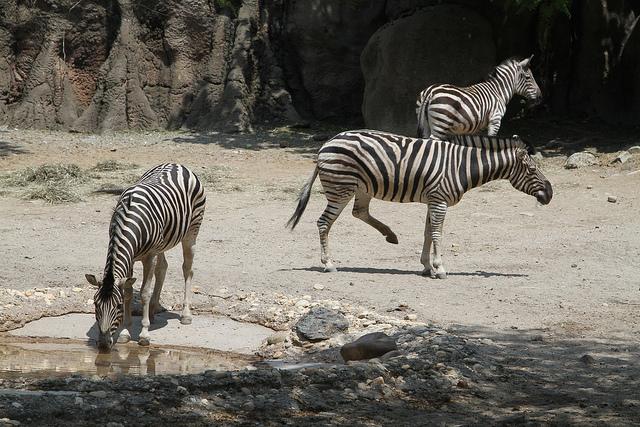Where is this photo taken?
Keep it brief. Zoo. Is the zebra happy?
Write a very short answer. Yes. How many zebra are fighting?
Keep it brief. 0. Are the zebras close to each other?
Quick response, please. Yes. How many zebras are in the image?
Short answer required. 3. Are the zebras looking in the same direction?
Concise answer only. No. What is the drinking giraffe doing with its forelegs?
Short answer required. Standing. How many zebras are drinking water?
Quick response, please. 1. Where are the large rocks?
Give a very brief answer. Background. Do these animals have spots or stripes?
Answer briefly. Stripes. 